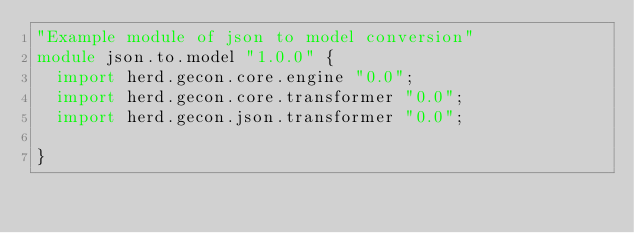<code> <loc_0><loc_0><loc_500><loc_500><_Ceylon_>"Example module of json to model conversion"
module json.to.model "1.0.0" {
	import herd.gecon.core.engine "0.0";
	import herd.gecon.core.transformer "0.0";
	import herd.gecon.json.transformer "0.0";
	
}
</code> 